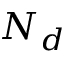Convert formula to latex. <formula><loc_0><loc_0><loc_500><loc_500>N _ { d }</formula> 